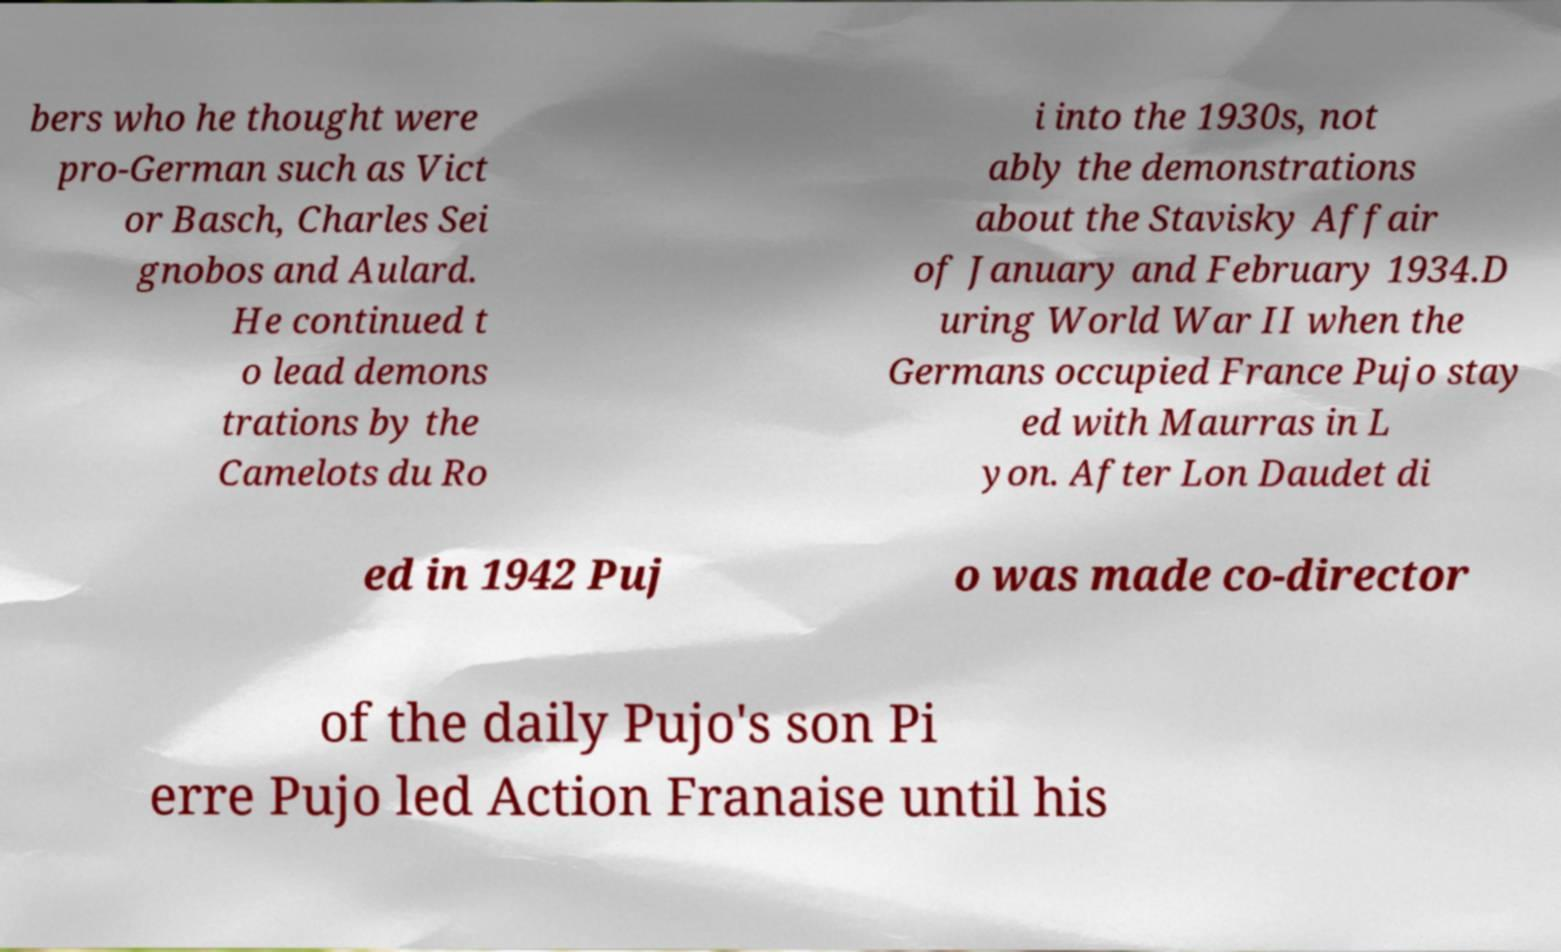For documentation purposes, I need the text within this image transcribed. Could you provide that? bers who he thought were pro-German such as Vict or Basch, Charles Sei gnobos and Aulard. He continued t o lead demons trations by the Camelots du Ro i into the 1930s, not ably the demonstrations about the Stavisky Affair of January and February 1934.D uring World War II when the Germans occupied France Pujo stay ed with Maurras in L yon. After Lon Daudet di ed in 1942 Puj o was made co-director of the daily Pujo's son Pi erre Pujo led Action Franaise until his 